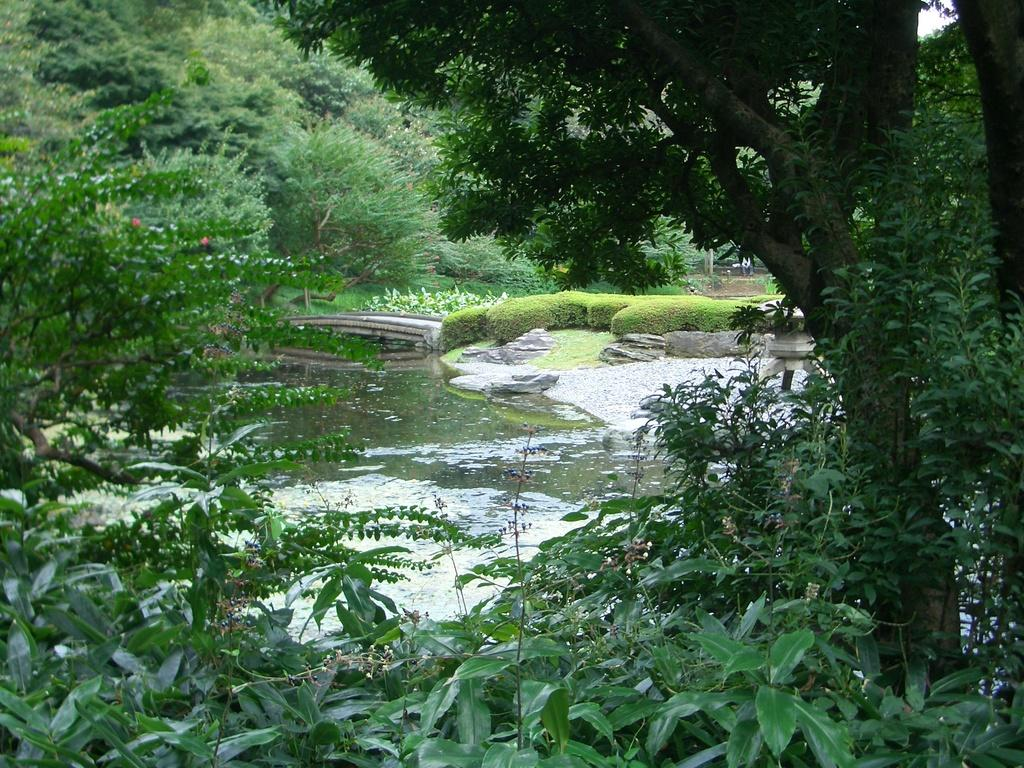What is the primary element in the image? There is water in the image. What can be seen near the water? There is ground visible near the water. What structure is present in the image? There is a railing in the image. What type of vegetation is present in the image? Plants are present in the image, and there are many trees around the water. What is visible in the background of the image? The sky is visible in the background of the image. What is the fireman reading in the image? There is no fireman or any reading material present in the image. 